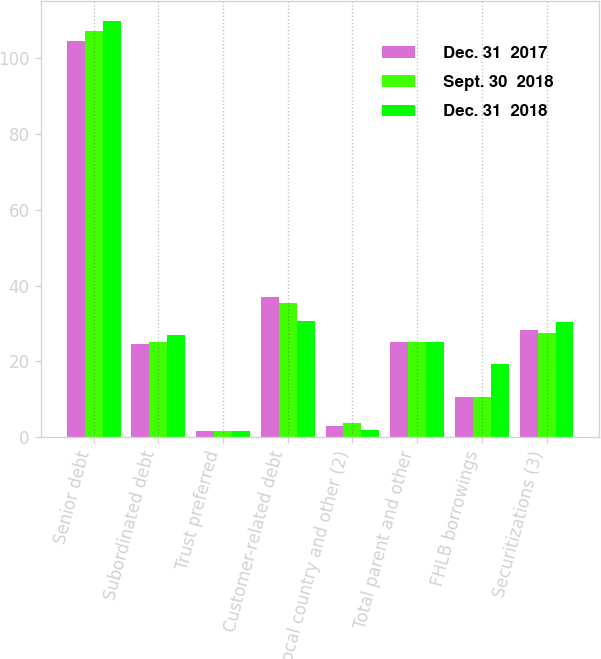Convert chart to OTSL. <chart><loc_0><loc_0><loc_500><loc_500><stacked_bar_chart><ecel><fcel>Senior debt<fcel>Subordinated debt<fcel>Trust preferred<fcel>Customer-related debt<fcel>Local country and other (2)<fcel>Total parent and other<fcel>FHLB borrowings<fcel>Securitizations (3)<nl><fcel>Dec. 31  2017<fcel>104.6<fcel>24.5<fcel>1.7<fcel>37.1<fcel>2.9<fcel>25.1<fcel>10.5<fcel>28.4<nl><fcel>Sept. 30  2018<fcel>107.2<fcel>25.1<fcel>1.7<fcel>35.4<fcel>3.8<fcel>25.1<fcel>10.5<fcel>27.4<nl><fcel>Dec. 31  2018<fcel>109.8<fcel>26.9<fcel>1.7<fcel>30.7<fcel>1.8<fcel>25.1<fcel>19.3<fcel>30.3<nl></chart> 